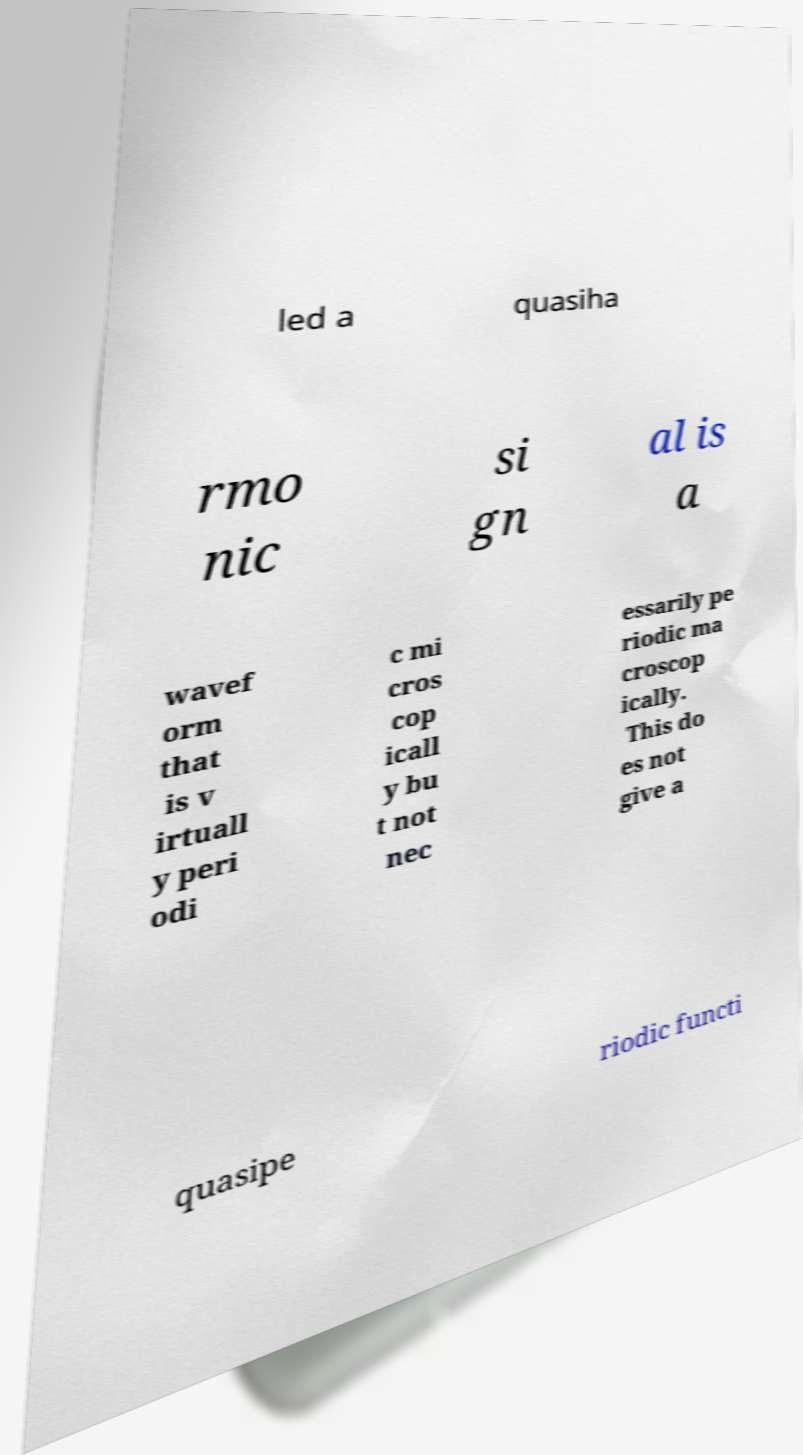I need the written content from this picture converted into text. Can you do that? led a quasiha rmo nic si gn al is a wavef orm that is v irtuall y peri odi c mi cros cop icall y bu t not nec essarily pe riodic ma croscop ically. This do es not give a quasipe riodic functi 